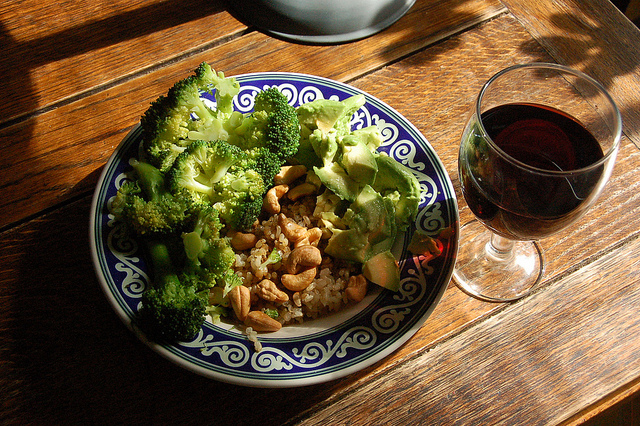<image>Does it taste better with the wine? It's ambiguous if it tastes better with the wine. It depends on personal preference. Does it taste better with the wine? I don't know if it tastes better with wine. It depends on whether one likes wine or not. 